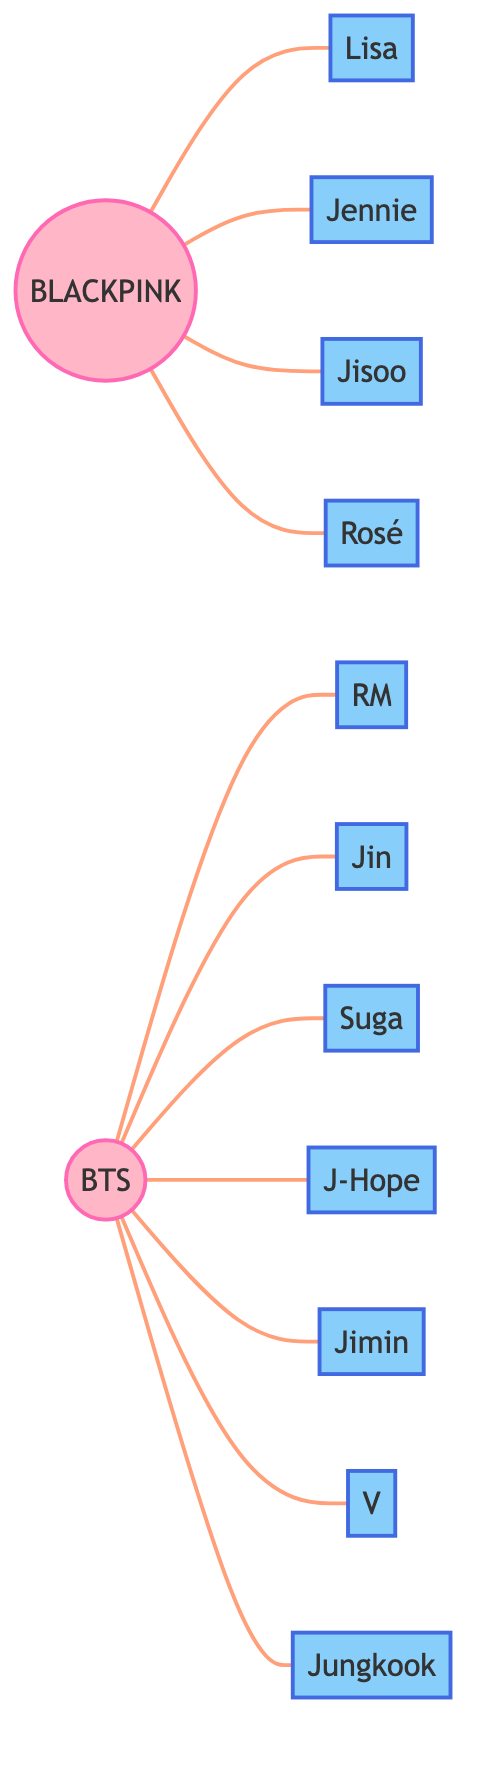What's the total number of K-pop idol groups in the diagram? There are two nodes that represent K-pop idol groups: BLACKPINK and BTS. Counting these gives a total of 2 groups.
Answer: 2 How many members are associated with BLACKPINK? The edges connected to BLACKPINK are to four members: Lisa, Jennie, Jisoo, and Rosé. Counting these gives a total of 4 members.
Answer: 4 Which member is connected to both BLACKPINK and BTS? There are no connections between BLACKPINK and BTS shown in the edges. Thus, there is no member that is connected to both groups.
Answer: None What's the name of the member associated with the K-pop group BTS who is listed last? The last member listed for BTS in the edges is Jungkook, as he is the last node directly connected to BTS.
Answer: Jungkook Which group has the most members in the diagram? BLACKPINK has 4 members while BTS has 7 members. Since BTS has more members, it is the group with the most members.
Answer: BTS How many edges are in the diagram for BTS? There are 7 edges connected to BTS, each representing a member (RM, Jin, Suga, J-Hope, Jimin, V, Jungkook). Counting these gives a total of 7 edges.
Answer: 7 Are the edges directed or undirected in this diagram? The description of the connections in the diagram indicates that it is an undirected graph, meaning each edge connects two nodes without a specific direction.
Answer: Undirected Which member of BTS shares the same initial as the group? The member who shares the same initial "B" as BTS is Jin. Both names start with the letter "B" when considering the sound of "B".
Answer: Jin 